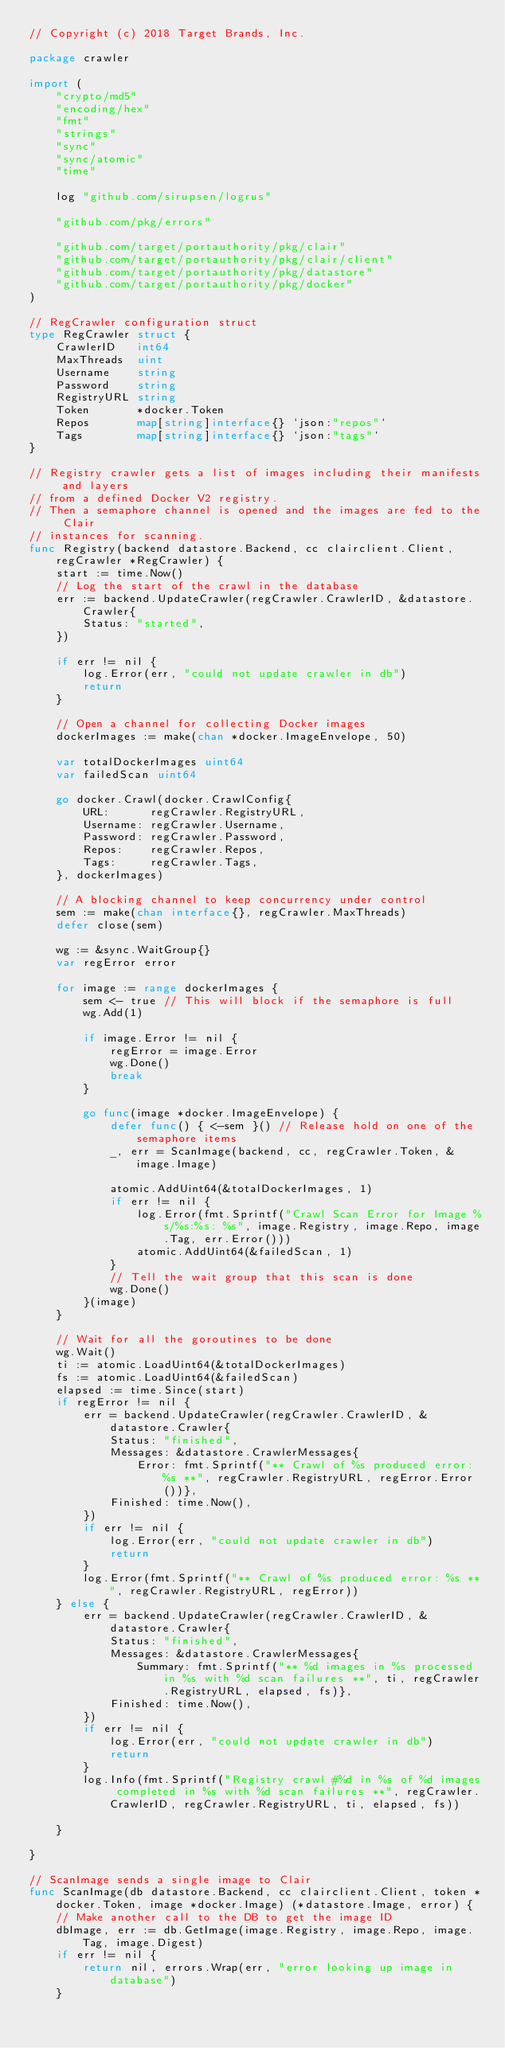Convert code to text. <code><loc_0><loc_0><loc_500><loc_500><_Go_>// Copyright (c) 2018 Target Brands, Inc.

package crawler

import (
	"crypto/md5"
	"encoding/hex"
	"fmt"
	"strings"
	"sync"
	"sync/atomic"
	"time"

	log "github.com/sirupsen/logrus"

	"github.com/pkg/errors"

	"github.com/target/portauthority/pkg/clair"
	"github.com/target/portauthority/pkg/clair/client"
	"github.com/target/portauthority/pkg/datastore"
	"github.com/target/portauthority/pkg/docker"
)

// RegCrawler configuration struct
type RegCrawler struct {
	CrawlerID   int64
	MaxThreads  uint
	Username    string
	Password    string
	RegistryURL string
	Token       *docker.Token
	Repos       map[string]interface{} `json:"repos"`
	Tags        map[string]interface{} `json:"tags"`
}

// Registry crawler gets a list of images including their manifests and layers
// from a defined Docker V2 registry.
// Then a semaphore channel is opened and the images are fed to the Clair
// instances for scanning.
func Registry(backend datastore.Backend, cc clairclient.Client, regCrawler *RegCrawler) {
	start := time.Now()
	// Log the start of the crawl in the database
	err := backend.UpdateCrawler(regCrawler.CrawlerID, &datastore.Crawler{
		Status: "started",
	})

	if err != nil {
		log.Error(err, "could not update crawler in db")
		return
	}

	// Open a channel for collecting Docker images
	dockerImages := make(chan *docker.ImageEnvelope, 50)

	var totalDockerImages uint64
	var failedScan uint64

	go docker.Crawl(docker.CrawlConfig{
		URL:      regCrawler.RegistryURL,
		Username: regCrawler.Username,
		Password: regCrawler.Password,
		Repos:    regCrawler.Repos,
		Tags:     regCrawler.Tags,
	}, dockerImages)

	// A blocking channel to keep concurrency under control
	sem := make(chan interface{}, regCrawler.MaxThreads)
	defer close(sem)

	wg := &sync.WaitGroup{}
	var regError error

	for image := range dockerImages {
		sem <- true // This will block if the semaphore is full
		wg.Add(1)

		if image.Error != nil {
			regError = image.Error
			wg.Done()
			break
		}

		go func(image *docker.ImageEnvelope) {
			defer func() { <-sem }() // Release hold on one of the semaphore items
			_, err = ScanImage(backend, cc, regCrawler.Token, &image.Image)

			atomic.AddUint64(&totalDockerImages, 1)
			if err != nil {
				log.Error(fmt.Sprintf("Crawl Scan Error for Image %s/%s:%s: %s", image.Registry, image.Repo, image.Tag, err.Error()))
				atomic.AddUint64(&failedScan, 1)
			}
			// Tell the wait group that this scan is done
			wg.Done()
		}(image)
	}

	// Wait for all the goroutines to be done
	wg.Wait()
	ti := atomic.LoadUint64(&totalDockerImages)
	fs := atomic.LoadUint64(&failedScan)
	elapsed := time.Since(start)
	if regError != nil {
		err = backend.UpdateCrawler(regCrawler.CrawlerID, &datastore.Crawler{
			Status: "finished",
			Messages: &datastore.CrawlerMessages{
				Error: fmt.Sprintf("** Crawl of %s produced error: %s **", regCrawler.RegistryURL, regError.Error())},
			Finished: time.Now(),
		})
		if err != nil {
			log.Error(err, "could not update crawler in db")
			return
		}
		log.Error(fmt.Sprintf("** Crawl of %s produced error: %s **", regCrawler.RegistryURL, regError))
	} else {
		err = backend.UpdateCrawler(regCrawler.CrawlerID, &datastore.Crawler{
			Status: "finished",
			Messages: &datastore.CrawlerMessages{
				Summary: fmt.Sprintf("** %d images in %s processed in %s with %d scan failures **", ti, regCrawler.RegistryURL, elapsed, fs)},
			Finished: time.Now(),
		})
		if err != nil {
			log.Error(err, "could not update crawler in db")
			return
		}
		log.Info(fmt.Sprintf("Registry crawl #%d in %s of %d images completed in %s with %d scan failures **", regCrawler.CrawlerID, regCrawler.RegistryURL, ti, elapsed, fs))

	}

}

// ScanImage sends a single image to Clair
func ScanImage(db datastore.Backend, cc clairclient.Client, token *docker.Token, image *docker.Image) (*datastore.Image, error) {
	// Make another call to the DB to get the image ID
	dbImage, err := db.GetImage(image.Registry, image.Repo, image.Tag, image.Digest)
	if err != nil {
		return nil, errors.Wrap(err, "error looking up image in database")
	}
</code> 